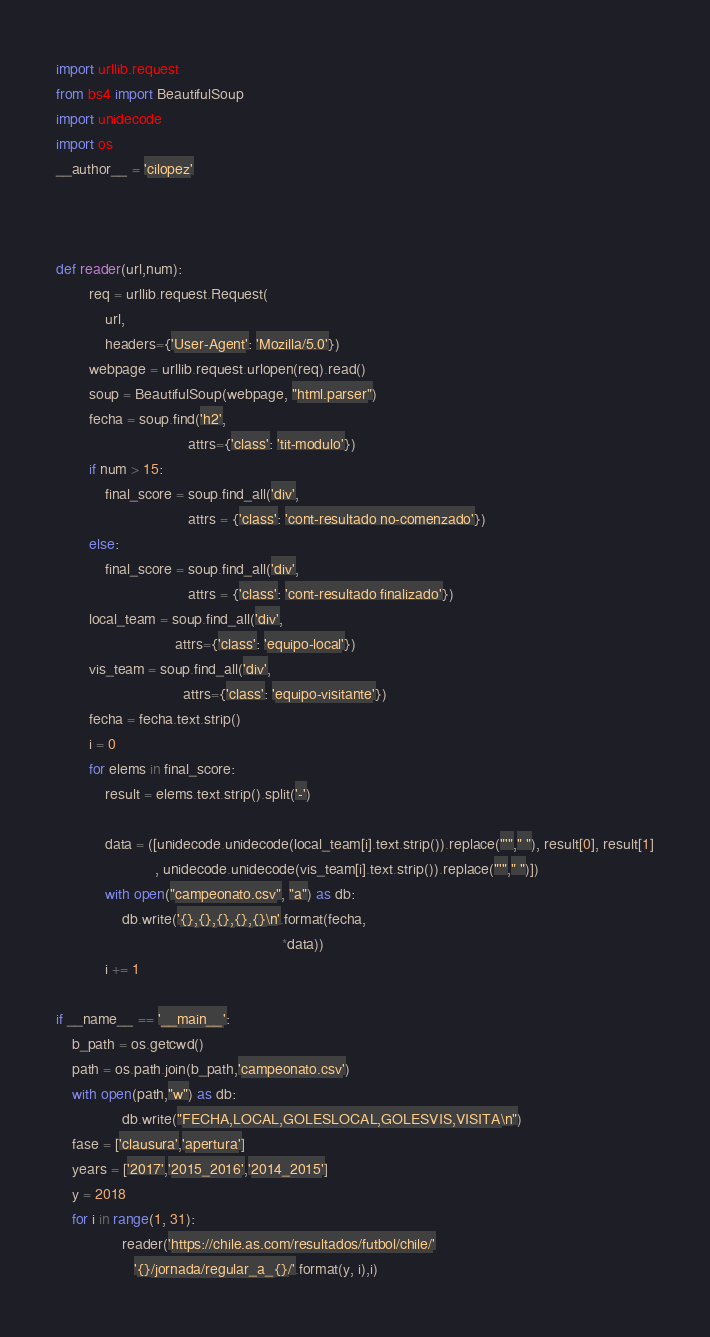Convert code to text. <code><loc_0><loc_0><loc_500><loc_500><_Python_>import urllib.request
from bs4 import BeautifulSoup
import unidecode
import os
__author__ = 'cilopez'



def reader(url,num):
        req = urllib.request.Request(
            url,
            headers={'User-Agent': 'Mozilla/5.0'})
        webpage = urllib.request.urlopen(req).read()
        soup = BeautifulSoup(webpage, "html.parser")
        fecha = soup.find('h2',
                                attrs={'class': 'tit-modulo'})
        if num > 15:
            final_score = soup.find_all('div',
                                attrs = {'class': 'cont-resultado no-comenzado'})
        else:   
            final_score = soup.find_all('div',
                                attrs = {'class': 'cont-resultado finalizado'})
        local_team = soup.find_all('div',
                             attrs={'class': 'equipo-local'})
        vis_team = soup.find_all('div',
                               attrs={'class': 'equipo-visitante'})
        fecha = fecha.text.strip()
        i = 0
        for elems in final_score:
            result = elems.text.strip().split('-')
            
            data = ([unidecode.unidecode(local_team[i].text.strip()).replace("'"," "), result[0], result[1]
                        , unidecode.unidecode(vis_team[i].text.strip()).replace("'"," ")])
            with open("campeonato.csv", "a") as db:
                db.write('{},{},{},{},{}\n'.format(fecha,
                                                       *data))
            i += 1

if __name__ == '__main__':
    b_path = os.getcwd()
    path = os.path.join(b_path,'campeonato.csv')
    with open(path,"w") as db:
                db.write("FECHA,LOCAL,GOLESLOCAL,GOLESVIS,VISITA\n")
    fase = ['clausura','apertura']
    years = ['2017','2015_2016','2014_2015']
    y = 2018
    for i in range(1, 31):
                reader('https://chile.as.com/resultados/futbol/chile/'
                   '{}/jornada/regular_a_{}/'.format(y, i),i)

</code> 